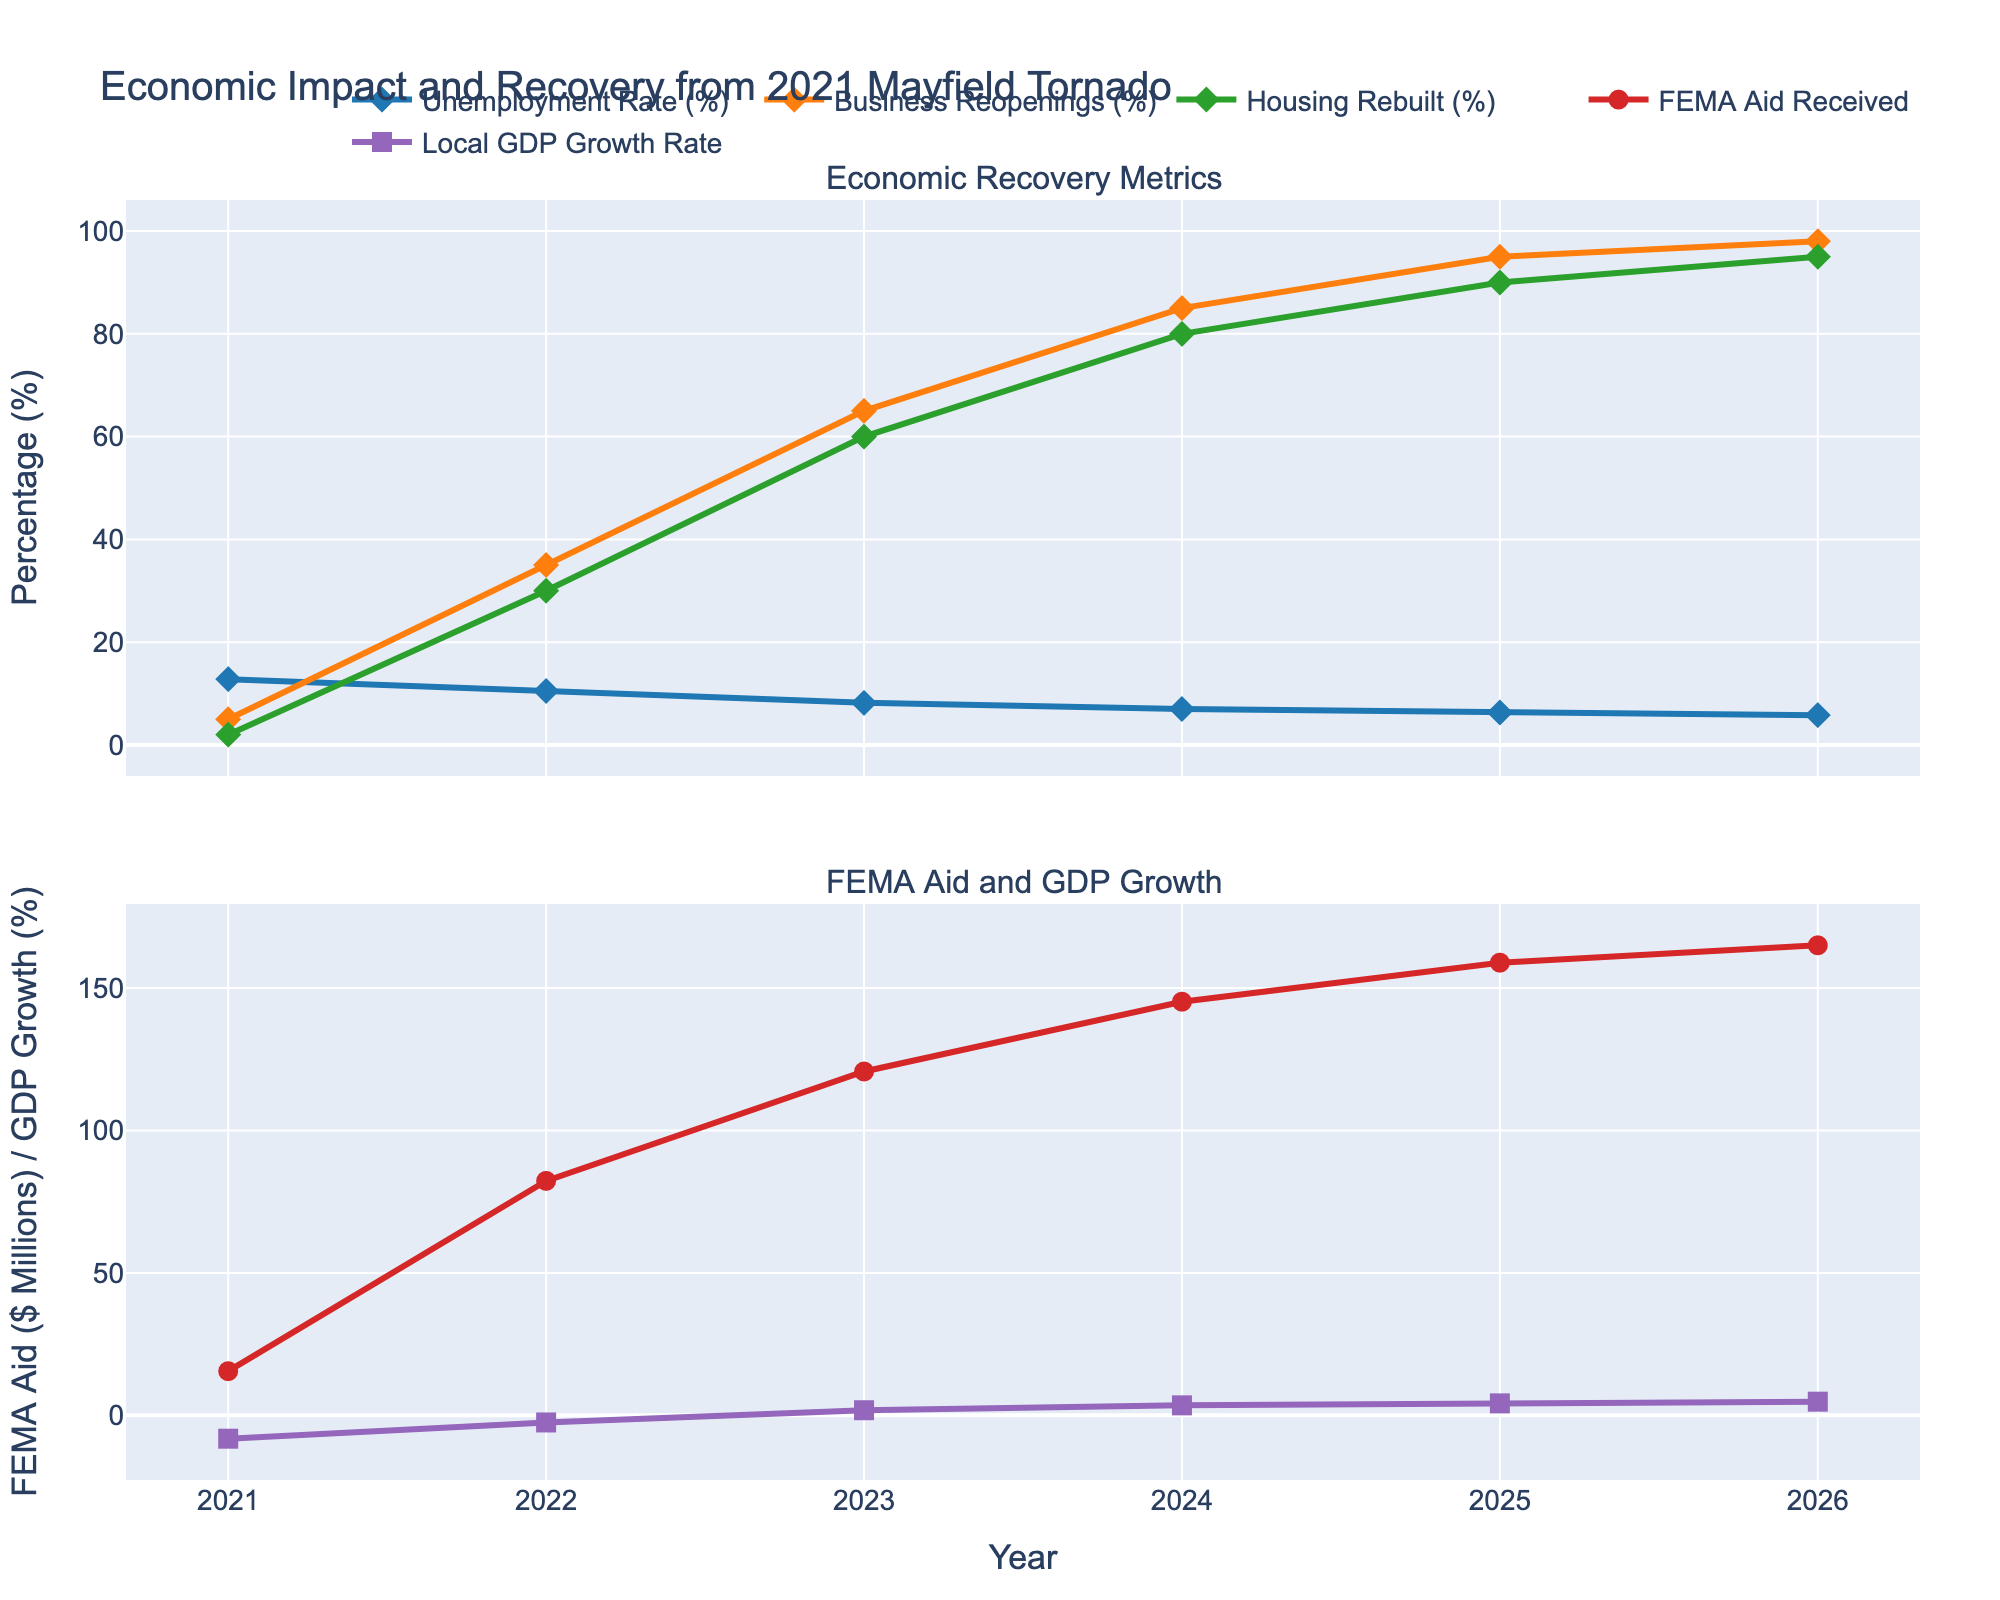What was the unemployment rate in 2021? The unemployment rate in 2021 is clearly marked on the line chart as the value on the first point of the Unemployment Rate (%) line.
Answer: 12.8% How much did the Local GDP Growth Rate (%) change from 2021 to 2023? Find the difference between the Local GDP Growth Rate (%) in 2023 and 2021. In 2023, it was 1.8%, and in 2021, it was -8.2%. So, the change is 1.8 - (-8.2) = 10.
Answer: 10% Which year saw the highest percentage of Business Reopenings? The highest point on the Business Reopenings (%) line chart corresponds to the year 2026.
Answer: 2026 By how much did FEMA Aid Received increase from 2022 to 2024? Subtract FEMA Aid Received in 2022 from FEMA Aid Received in 2024: 145.2 - 82.3 = 62.9.
Answer: 62.9 million dollars Did the Unemployment Rate (%) decrease or increase each year from 2021 to 2026? By analyzing the line trend for the Unemployment Rate (%), it consistently decreases from 2021 to 2026.
Answer: Decrease What is the median value of Housing Rebuilt (%) from 2021 to 2026? Arrange the Housing Rebuilt (%) values (2, 30, 60, 80, 90, 95) and find the median (average of the middle two values for an even number of data points): (60 + 80) / 2 = 70.
Answer: 70% How many years did it take for Business Reopenings (%) to reach 85% from 2021? Identify the year when Business Reopenings (%) is first listed as 85%, which is 2024. Subtract the initial year 2021: 2024 - 2021 = 3 years.
Answer: 3 years Which metric showed the most significant improvement from 2021 to 2026? Compare the difference for each metric over the period. Unemployment Rate decreases by 12.8 - 5.8 = 7%, Business Reopenings increases by 98 - 5 = 93%, Housing Rebuilt increases by 95 - 2 = 93%, FEMA Aid Received increases by 165.0 - 15.5 = 149.5 million dollars, Local GDP Growth Rate increases by 4.8 - (-8.2) = 13%. Business Reopenings and Housing Rebuilt both improved by 93%, but since they both had the same percentage, there is no single most significant improvement.
Answer: Business Reopenings (%) and Housing Rebuilt (%) Which year did FEMA Aid Received exceed 150 million dollars for the first time? Look at the FEMA Aid Received ($ Millions) line and identify the year for the first value that exceeds 150, which is 2025.
Answer: 2025 